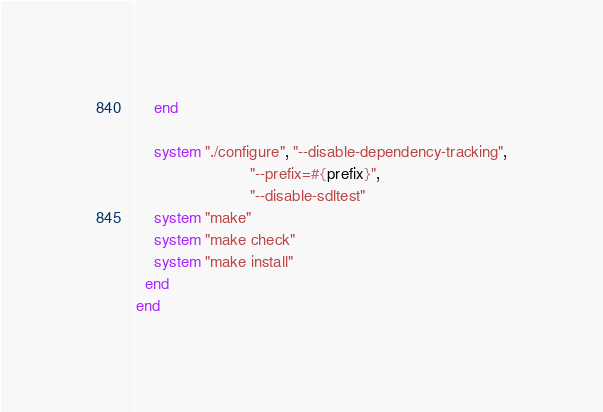<code> <loc_0><loc_0><loc_500><loc_500><_Ruby_>    end

    system "./configure", "--disable-dependency-tracking",
                          "--prefix=#{prefix}",
                          "--disable-sdltest"
    system "make"
    system "make check"
    system "make install"
  end
end
</code> 